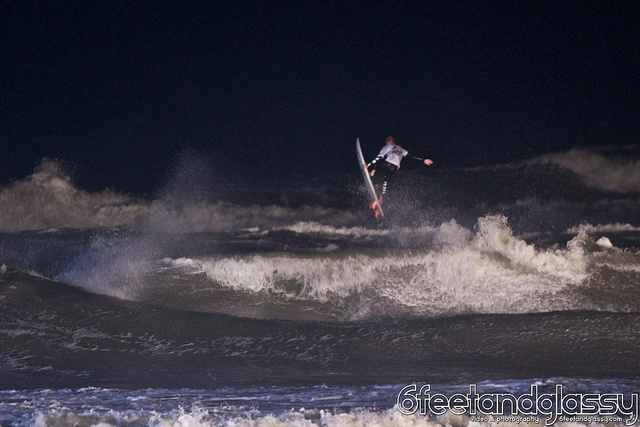Describe the objects in this image and their specific colors. I can see people in black, gray, darkgray, and brown tones and surfboard in black, gray, darkgray, brown, and lightpink tones in this image. 